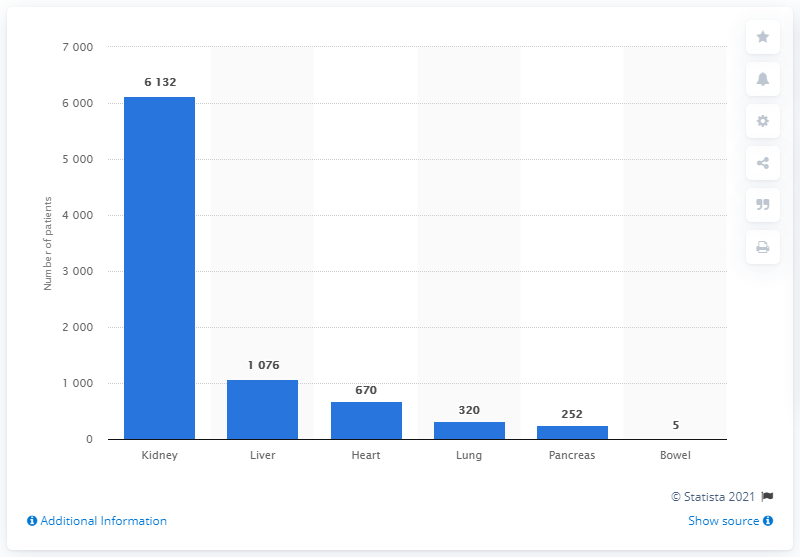Indicate a few pertinent items in this graphic. There were 320 patients in Italy who required a lung transplant in 2020. In 2020, there were 670 individuals in Italy who were in need of a heart transplant. 